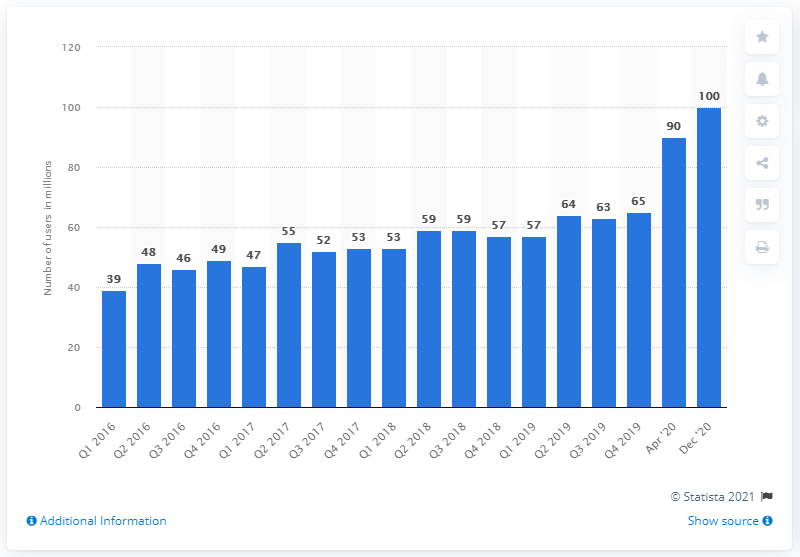Identify some key points in this picture. Xbox Live had 100 monthly active users as of [month/year]. 